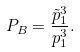<formula> <loc_0><loc_0><loc_500><loc_500>P _ { B } = \frac { \tilde { p } _ { 1 } ^ { 3 } } { p _ { 1 } ^ { 3 } } .</formula> 